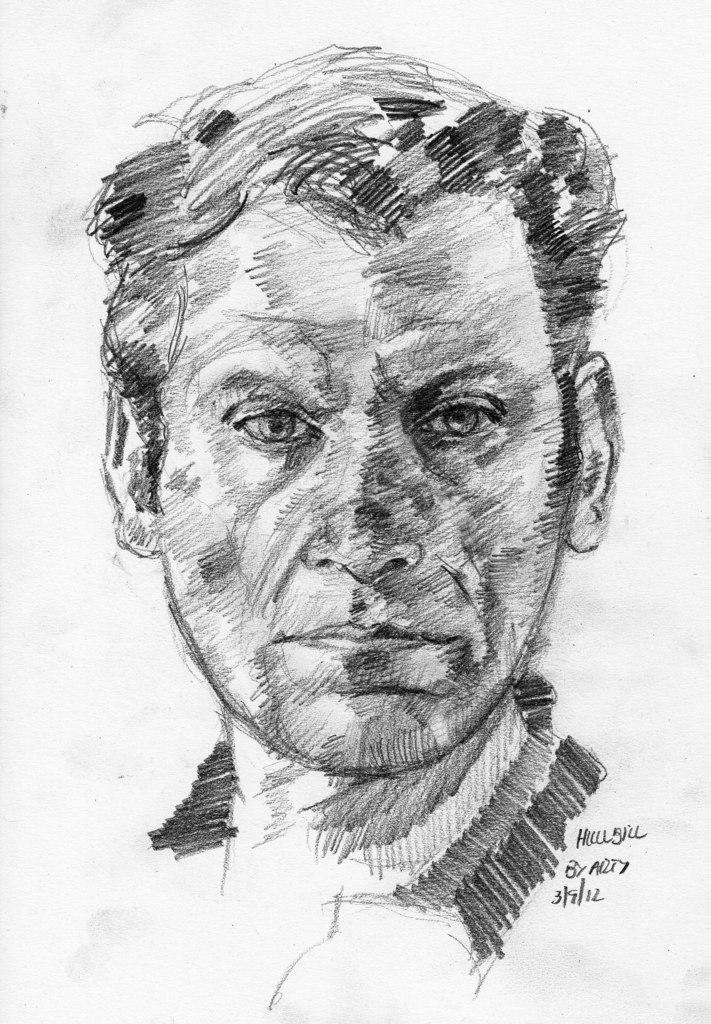What is depicted in the image? There is a drawing of a man in the image. What else is present in the image besides the drawing of the man? There is text in the image. How many sisters does the man in the drawing have? There is no information about the man's sisters in the image. What type of instrument is being played by the man in the drawing? There is no instrument present in the image, as it only features a drawing of a man and text. 